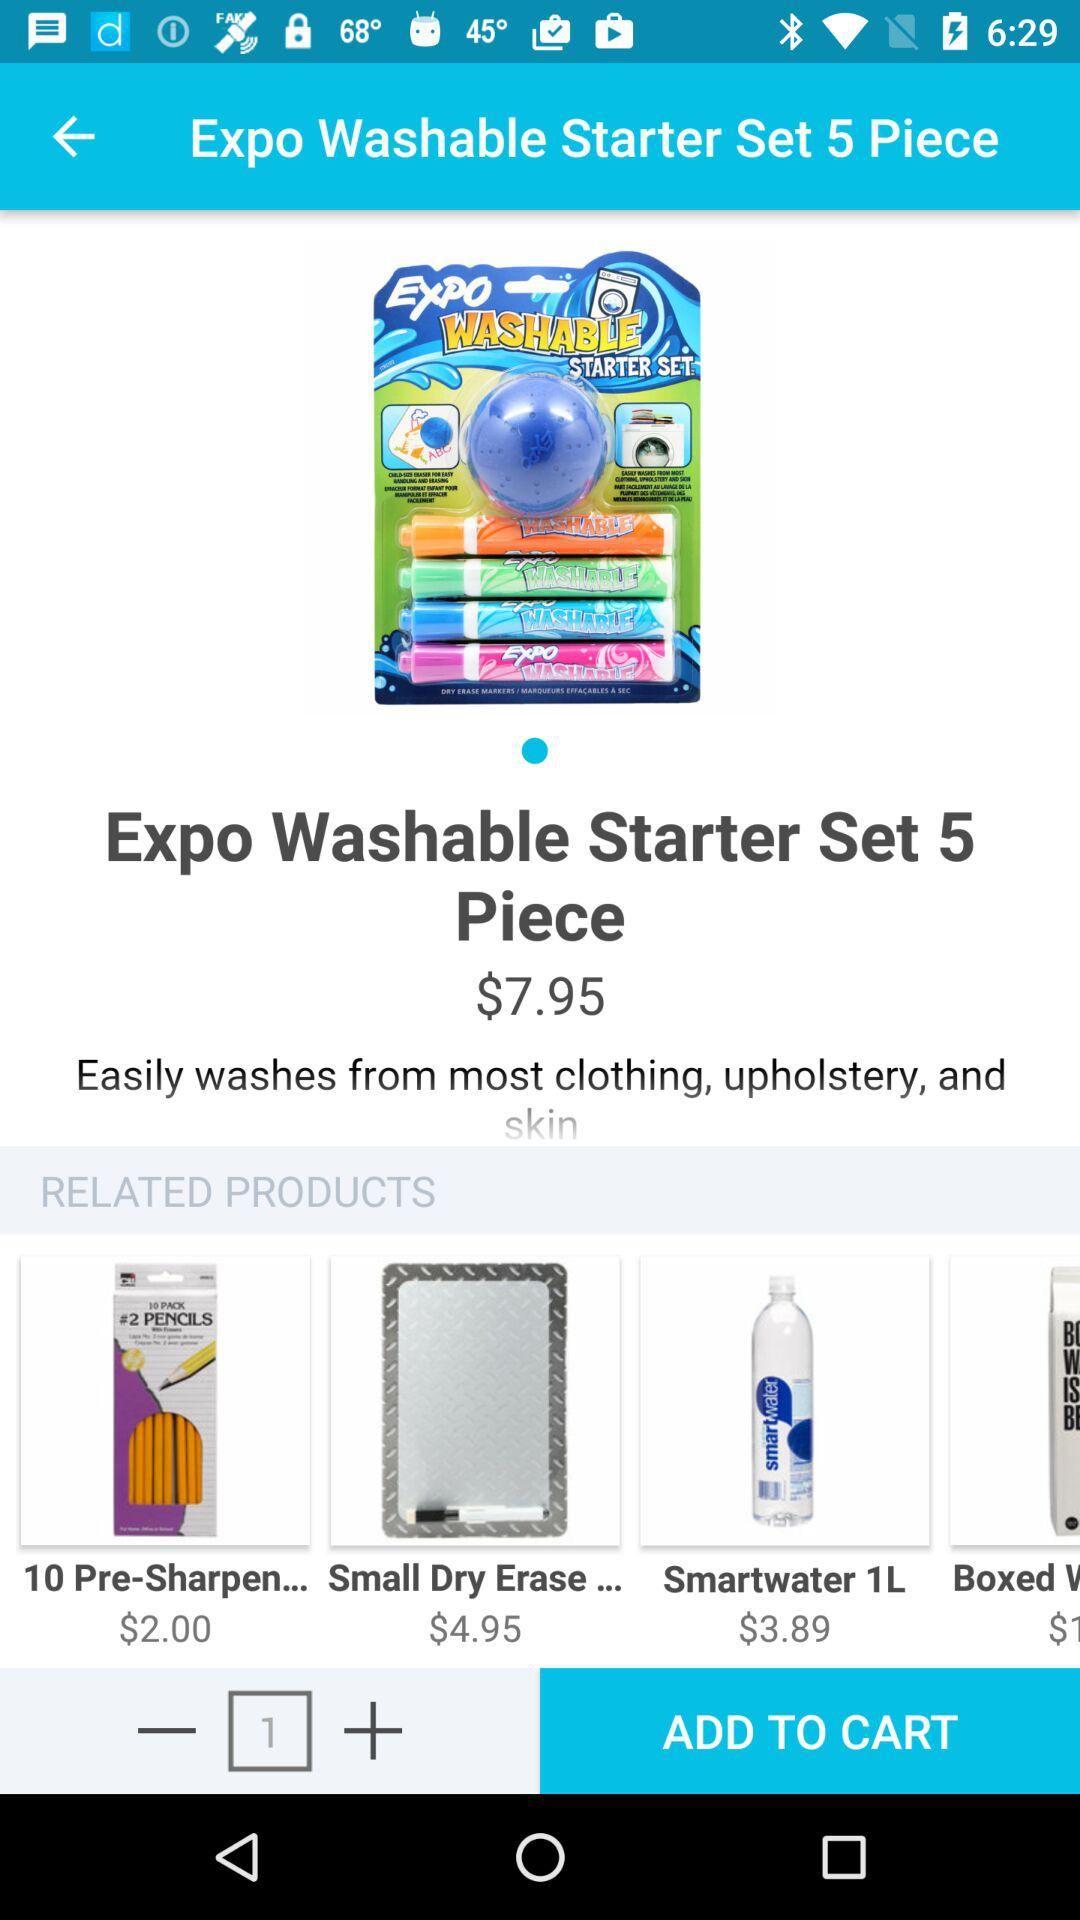How many pieces does the "Expo Washable Starter Set" consist of? The "Expo Washable Starter Set" consists of 5 pieces. 